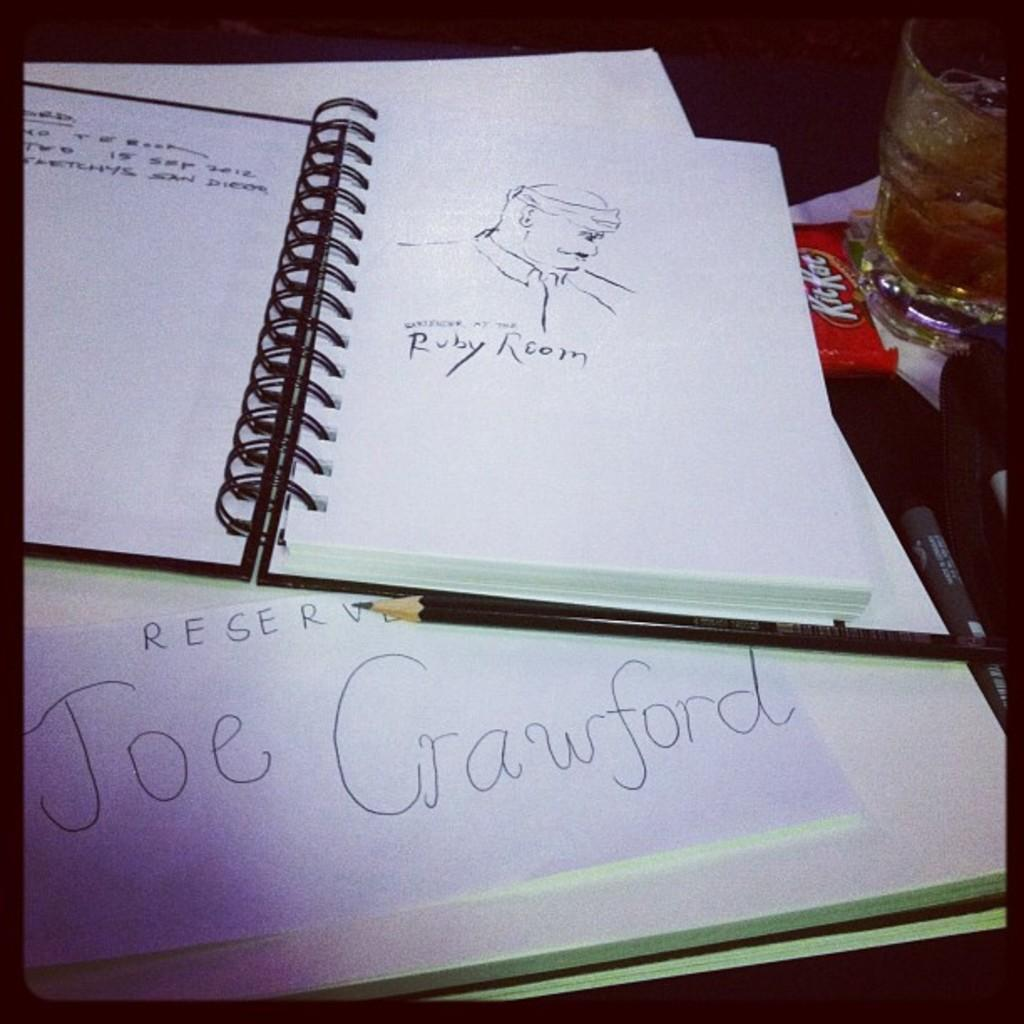<image>
Summarize the visual content of the image. An open notebook with a sketch of a man sits above a piece of paper reading Joe Crawford. 